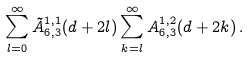<formula> <loc_0><loc_0><loc_500><loc_500>\sum _ { l = 0 } ^ { \infty } \tilde { A } _ { 6 , 3 } ^ { 1 , 1 } ( d + 2 l ) \sum _ { k = l } ^ { \infty } A _ { 6 , 3 } ^ { 1 , 2 } ( d + 2 k ) \, .</formula> 